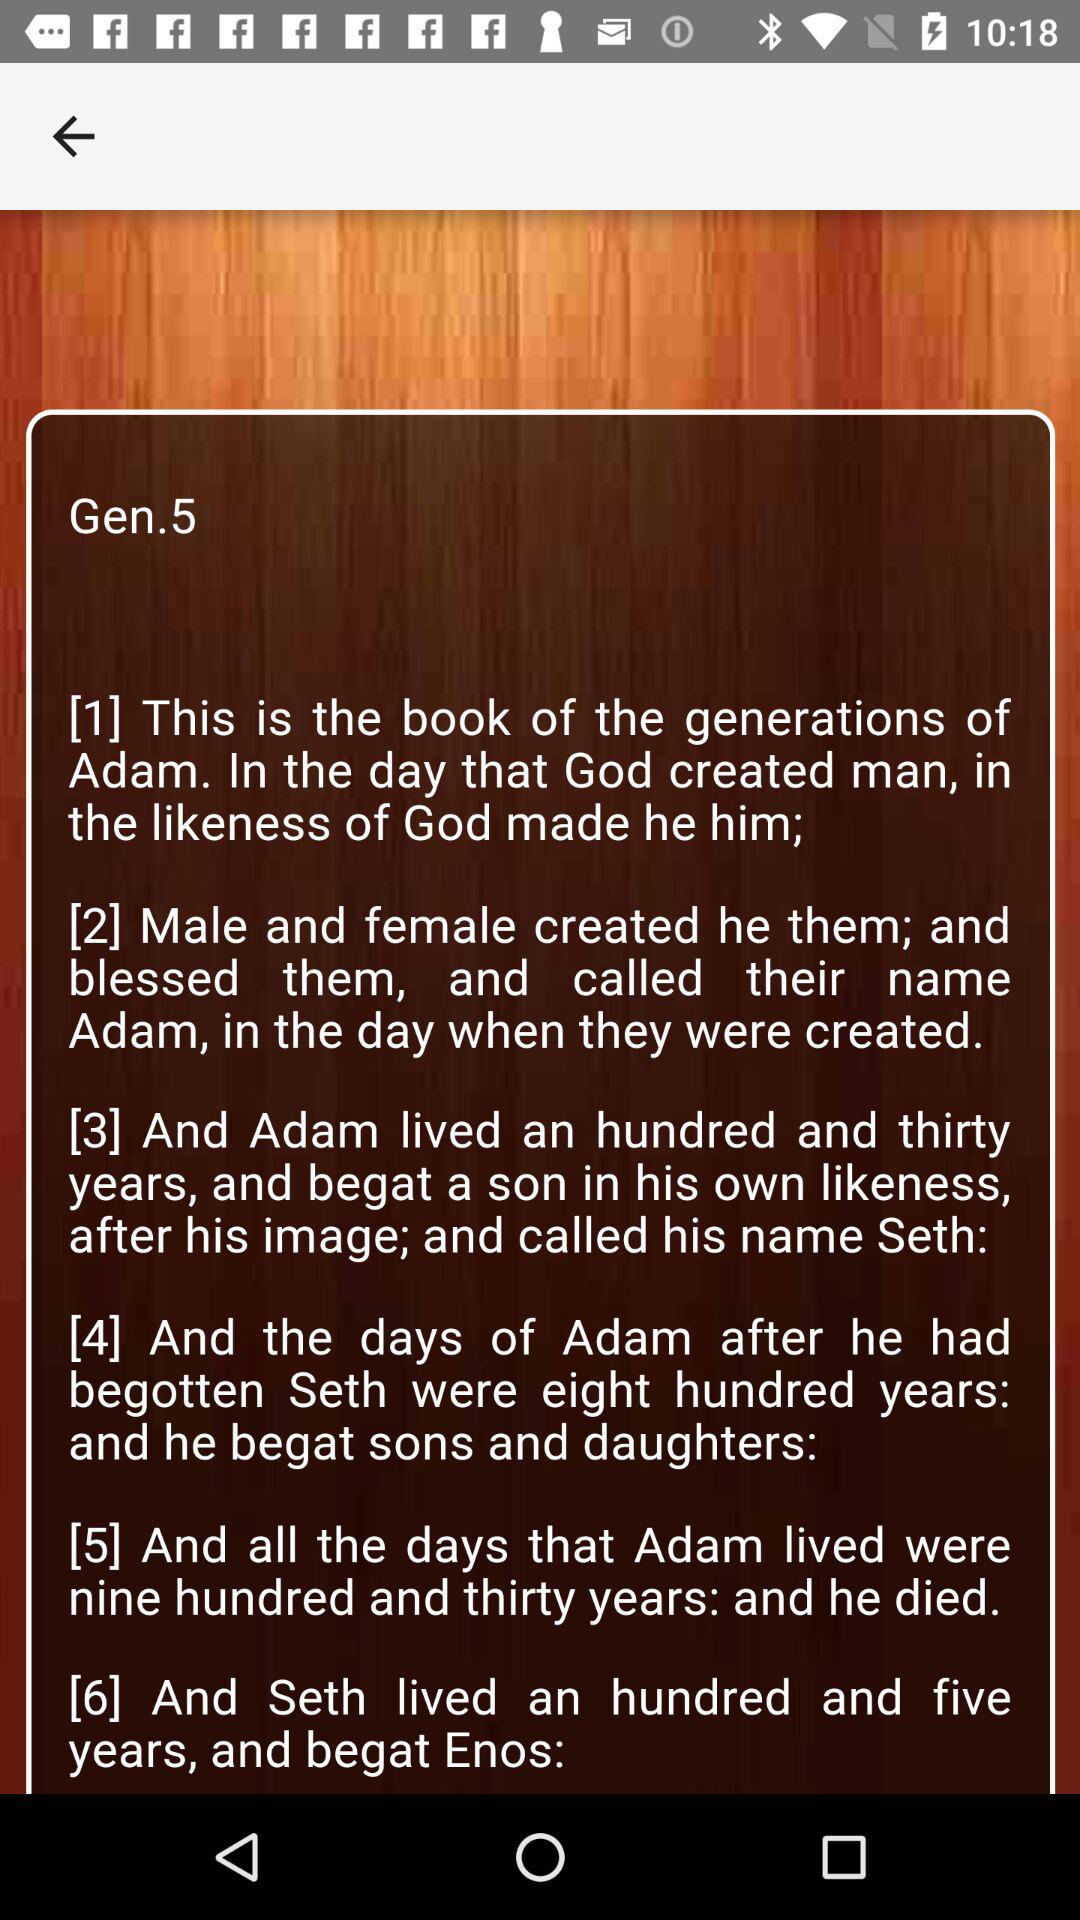How many verses are in the Bible passage?
Answer the question using a single word or phrase. 6 